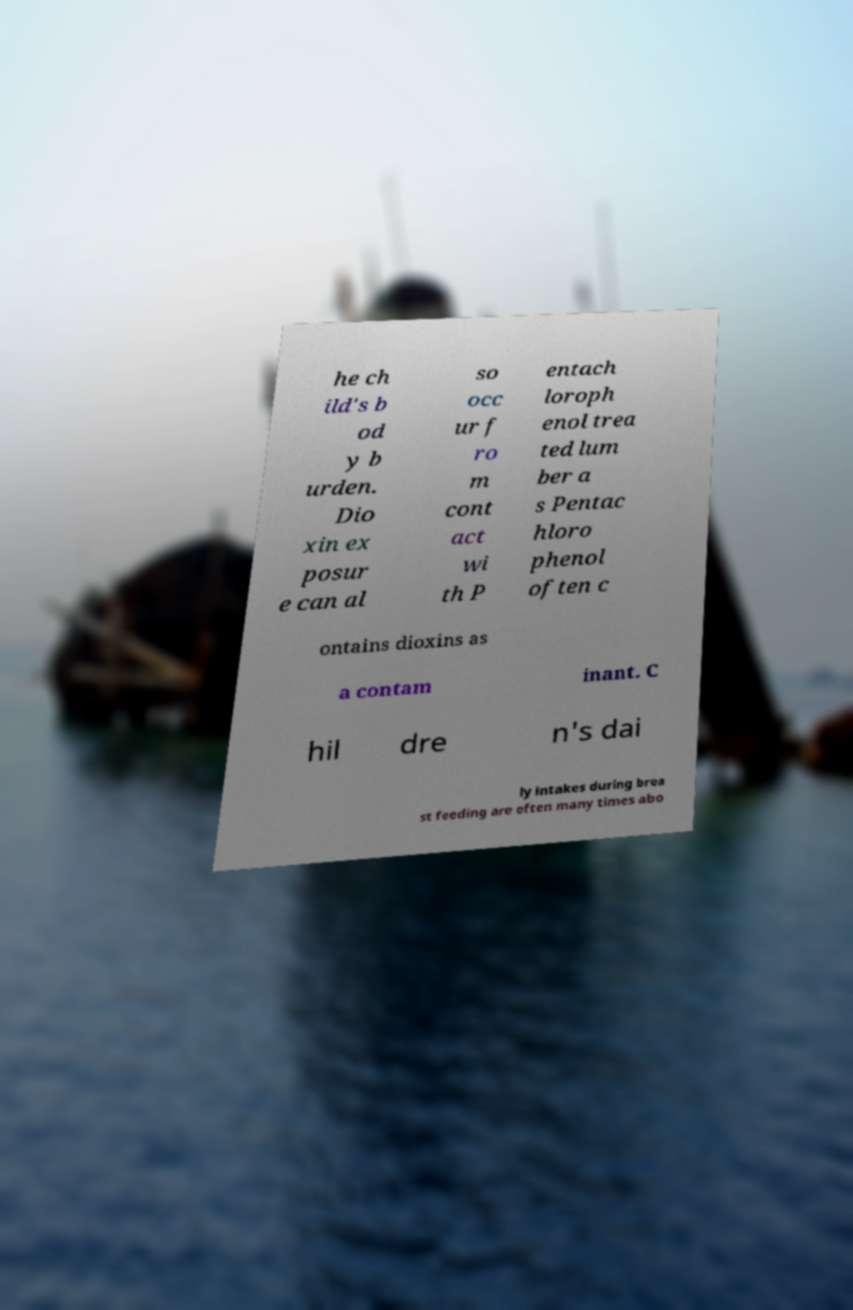I need the written content from this picture converted into text. Can you do that? he ch ild's b od y b urden. Dio xin ex posur e can al so occ ur f ro m cont act wi th P entach loroph enol trea ted lum ber a s Pentac hloro phenol often c ontains dioxins as a contam inant. C hil dre n's dai ly intakes during brea st feeding are often many times abo 